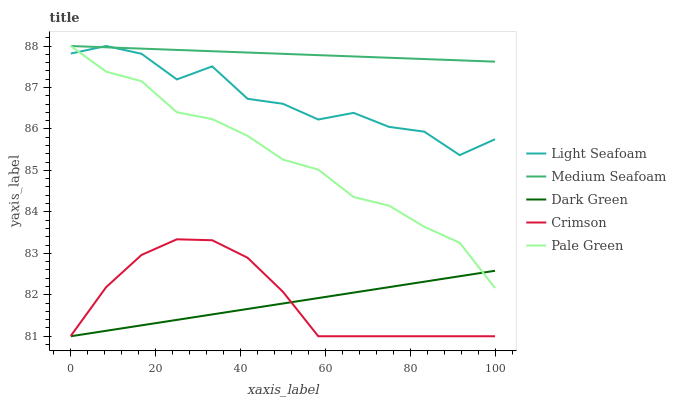Does Dark Green have the minimum area under the curve?
Answer yes or no. Yes. Does Medium Seafoam have the maximum area under the curve?
Answer yes or no. Yes. Does Pale Green have the minimum area under the curve?
Answer yes or no. No. Does Pale Green have the maximum area under the curve?
Answer yes or no. No. Is Medium Seafoam the smoothest?
Answer yes or no. Yes. Is Light Seafoam the roughest?
Answer yes or no. Yes. Is Pale Green the smoothest?
Answer yes or no. No. Is Pale Green the roughest?
Answer yes or no. No. Does Pale Green have the lowest value?
Answer yes or no. No. Does Medium Seafoam have the highest value?
Answer yes or no. Yes. Does Dark Green have the highest value?
Answer yes or no. No. Is Crimson less than Pale Green?
Answer yes or no. Yes. Is Medium Seafoam greater than Dark Green?
Answer yes or no. Yes. Does Crimson intersect Pale Green?
Answer yes or no. No. 